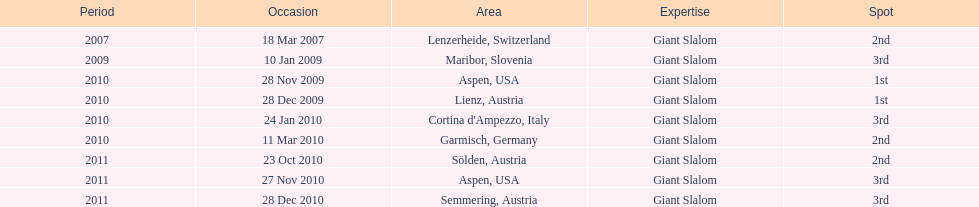The final race finishing place was not 1st but what other place? 3rd. 